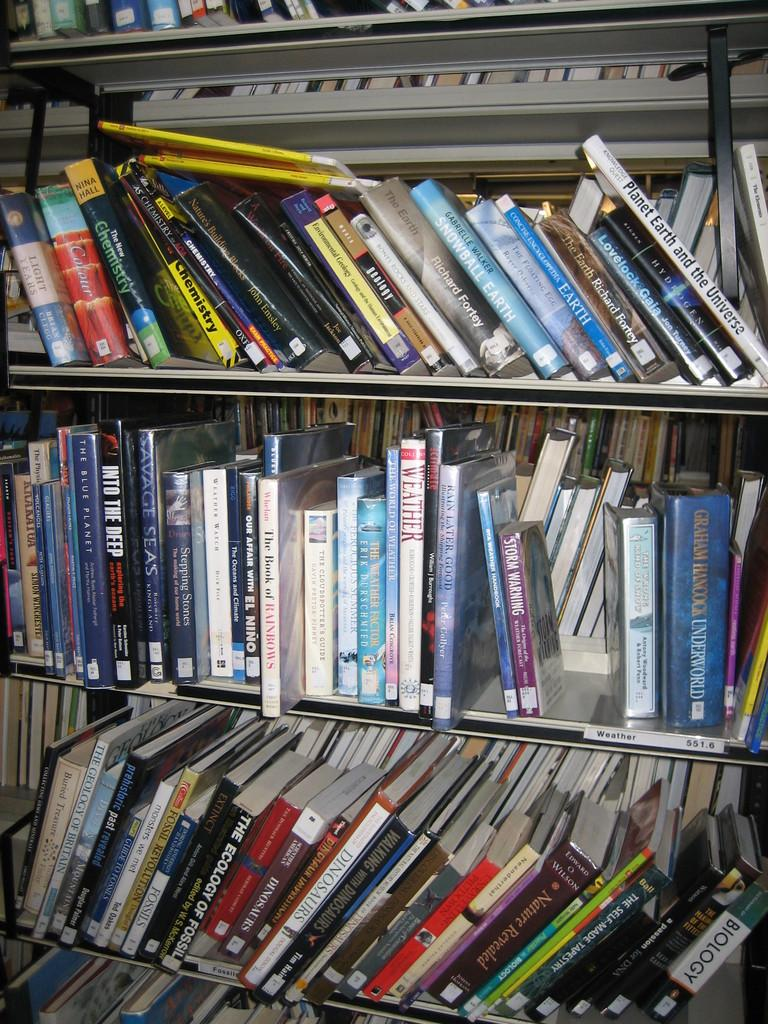What objects are in the image? There are books in a rack in the image. How are the books arranged in the image? The books are arranged in a rack in the image. What might the purpose of the books be? The books might be for reading or reference. What type of business is being conducted in the image? There is no indication of a business being conducted in the image; it only shows books in a rack. 